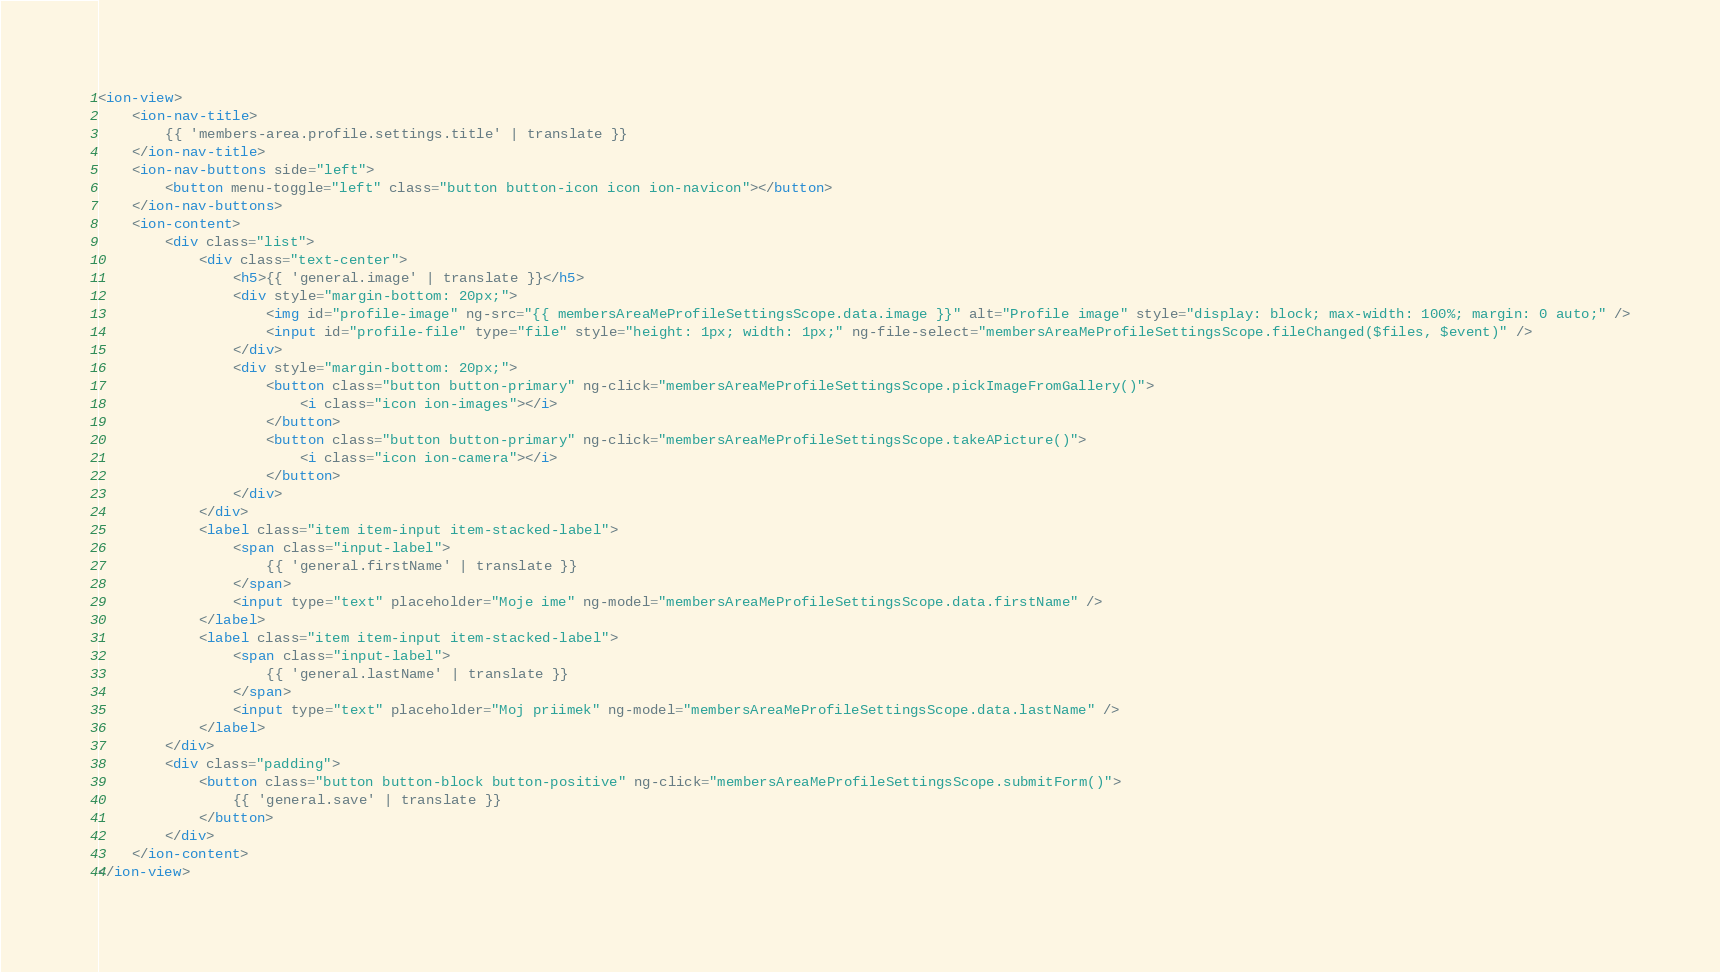Convert code to text. <code><loc_0><loc_0><loc_500><loc_500><_HTML_><ion-view>
	<ion-nav-title>
		{{ 'members-area.profile.settings.title' | translate }}
	</ion-nav-title>
	<ion-nav-buttons side="left">
		<button menu-toggle="left" class="button button-icon icon ion-navicon"></button>
	</ion-nav-buttons>
	<ion-content>
		<div class="list">
			<div class="text-center">
				<h5>{{ 'general.image' | translate }}</h5>
				<div style="margin-bottom: 20px;">
					<img id="profile-image" ng-src="{{ membersAreaMeProfileSettingsScope.data.image }}" alt="Profile image" style="display: block; max-width: 100%; margin: 0 auto;" />
					<input id="profile-file" type="file" style="height: 1px; width: 1px;" ng-file-select="membersAreaMeProfileSettingsScope.fileChanged($files, $event)" />
				</div>
				<div style="margin-bottom: 20px;">
					<button class="button button-primary" ng-click="membersAreaMeProfileSettingsScope.pickImageFromGallery()">
						<i class="icon ion-images"></i>
					</button>
					<button class="button button-primary" ng-click="membersAreaMeProfileSettingsScope.takeAPicture()">
						<i class="icon ion-camera"></i>
					</button>
				</div>
			</div>
			<label class="item item-input item-stacked-label">
				<span class="input-label">
					{{ 'general.firstName' | translate }}
				</span>
				<input type="text" placeholder="Moje ime" ng-model="membersAreaMeProfileSettingsScope.data.firstName" />
			</label>
			<label class="item item-input item-stacked-label">
				<span class="input-label">
					{{ 'general.lastName' | translate }}
				</span>
				<input type="text" placeholder="Moj priimek" ng-model="membersAreaMeProfileSettingsScope.data.lastName" />
			</label>
		</div>
		<div class="padding">
			<button class="button button-block button-positive" ng-click="membersAreaMeProfileSettingsScope.submitForm()">
				{{ 'general.save' | translate }}
			</button>
		</div>
	</ion-content>
</ion-view></code> 